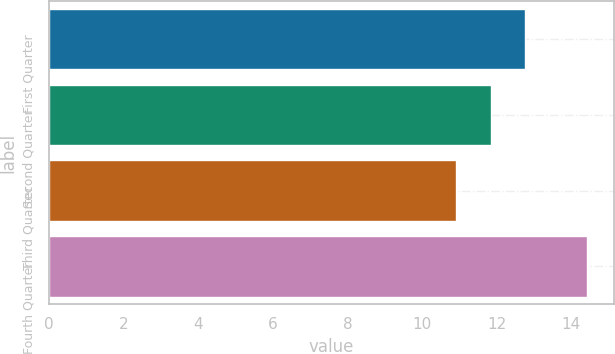Convert chart to OTSL. <chart><loc_0><loc_0><loc_500><loc_500><bar_chart><fcel>First Quarter<fcel>Second Quarter<fcel>Third Quarter<fcel>Fourth Quarter<nl><fcel>12.77<fcel>11.85<fcel>10.9<fcel>14.42<nl></chart> 